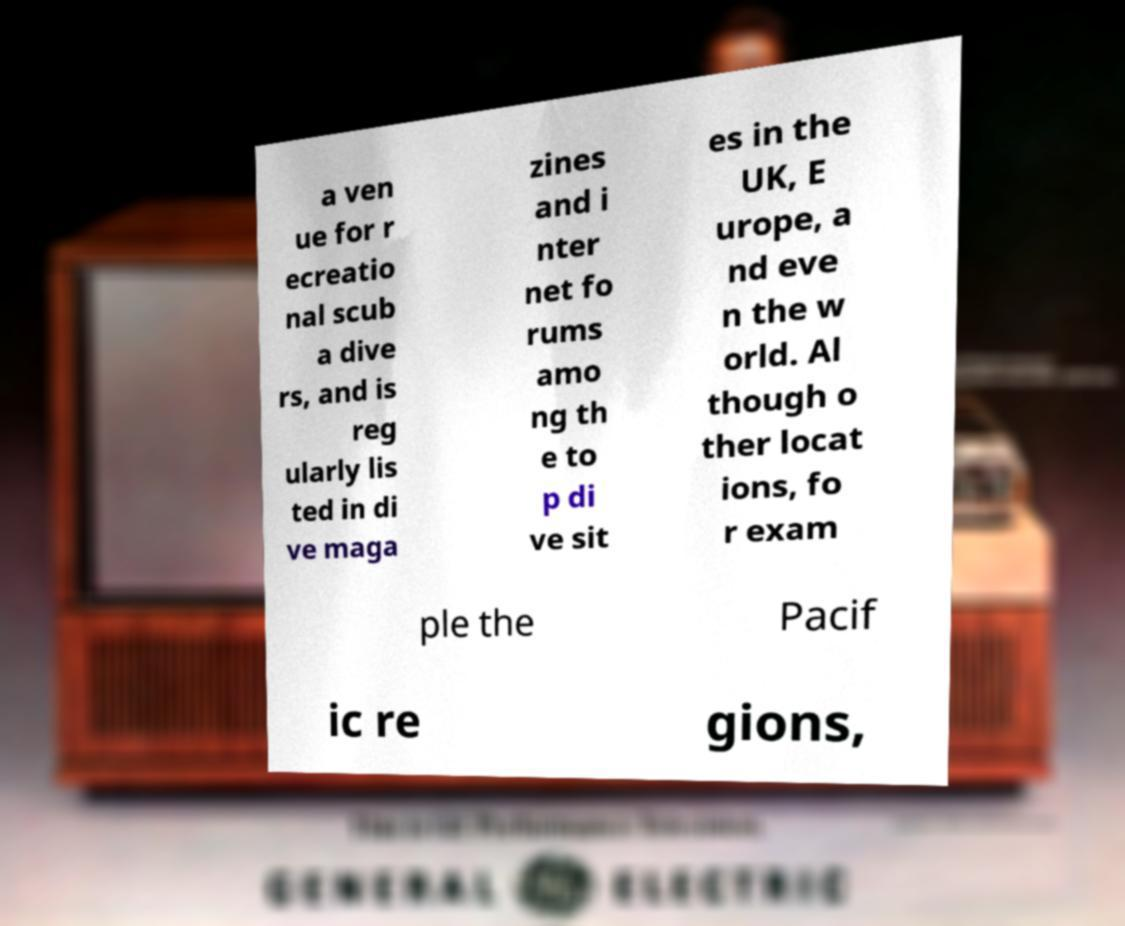Could you extract and type out the text from this image? a ven ue for r ecreatio nal scub a dive rs, and is reg ularly lis ted in di ve maga zines and i nter net fo rums amo ng th e to p di ve sit es in the UK, E urope, a nd eve n the w orld. Al though o ther locat ions, fo r exam ple the Pacif ic re gions, 